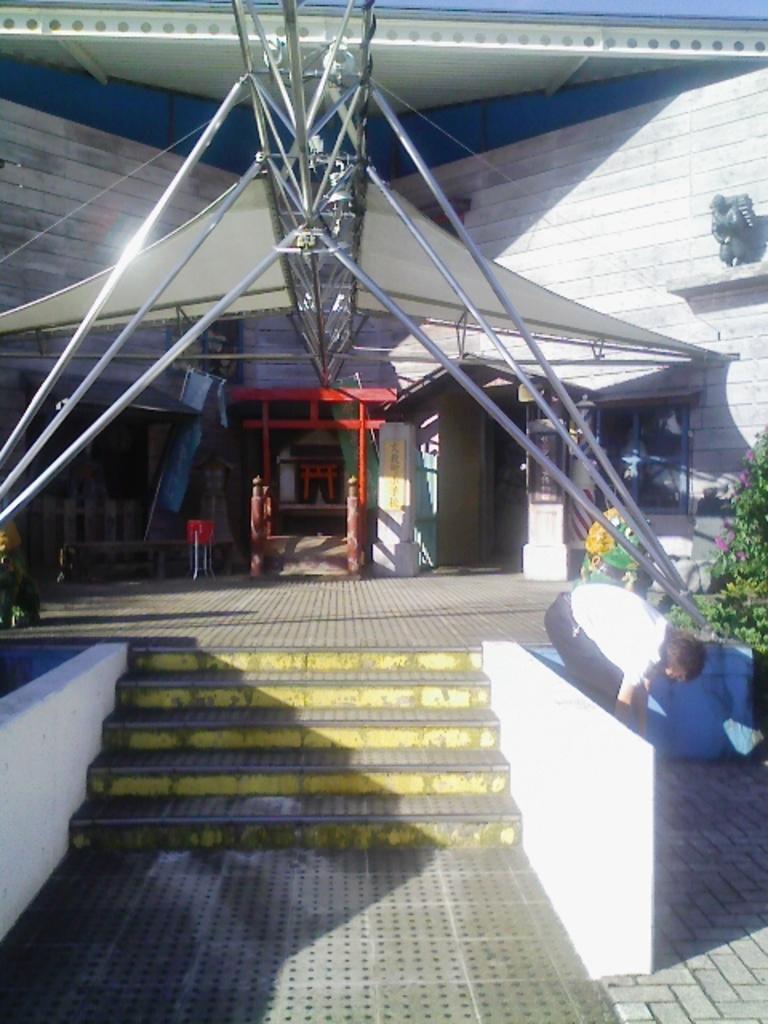How would you summarize this image in a sentence or two? In this image in the foreground there are steps. Here there is a building. On the right there are plants. Here there is a person. On the ground there are tiles. These are poles. 